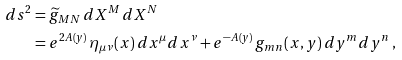<formula> <loc_0><loc_0><loc_500><loc_500>d s ^ { 2 } & = \widetilde { g } _ { M N } \, d X ^ { M } \, d X ^ { N } \\ & = e ^ { 2 A ( y ) } \, \eta _ { \mu \nu } ( x ) \, d x ^ { \mu } d x ^ { \nu } + e ^ { - A ( y ) } \, g _ { m n } ( x , y ) \, d y ^ { m } d y ^ { n } \, ,</formula> 